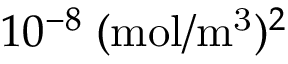<formula> <loc_0><loc_0><loc_500><loc_500>1 0 ^ { - 8 } \, ( m o l / m ^ { 3 } ) ^ { 2 }</formula> 